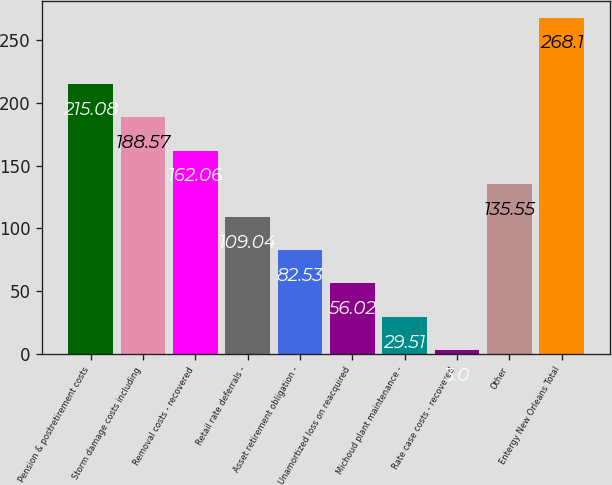<chart> <loc_0><loc_0><loc_500><loc_500><bar_chart><fcel>Pension & postretirement costs<fcel>Storm damage costs including<fcel>Removal costs - recovered<fcel>Retail rate deferrals -<fcel>Asset retirement obligation -<fcel>Unamortized loss on reacquired<fcel>Michoud plant maintenance -<fcel>Rate case costs - recovered<fcel>Other<fcel>Entergy New Orleans Total<nl><fcel>215.08<fcel>188.57<fcel>162.06<fcel>109.04<fcel>82.53<fcel>56.02<fcel>29.51<fcel>3<fcel>135.55<fcel>268.1<nl></chart> 